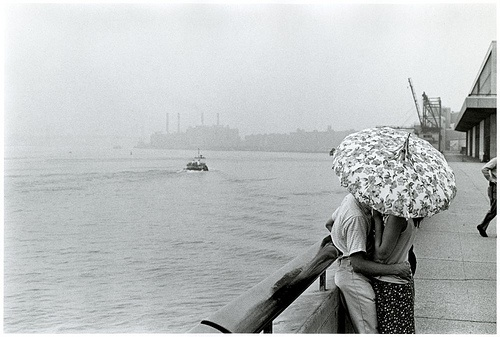Describe the objects in this image and their specific colors. I can see umbrella in white, lightgray, darkgray, gray, and black tones, people in white, darkgray, gray, black, and lightgray tones, people in white, black, gray, and darkgray tones, people in white, black, gray, darkgray, and lightgray tones, and boat in white, gray, darkgray, lightgray, and black tones in this image. 